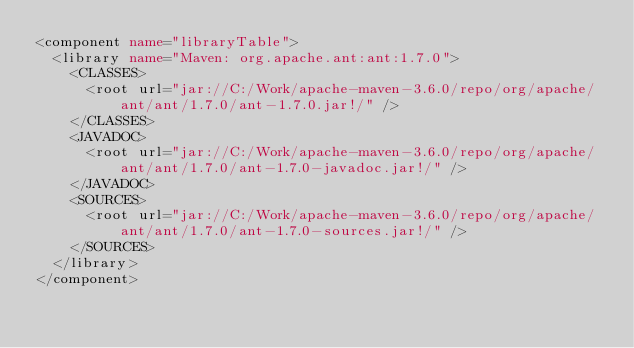Convert code to text. <code><loc_0><loc_0><loc_500><loc_500><_XML_><component name="libraryTable">
  <library name="Maven: org.apache.ant:ant:1.7.0">
    <CLASSES>
      <root url="jar://C:/Work/apache-maven-3.6.0/repo/org/apache/ant/ant/1.7.0/ant-1.7.0.jar!/" />
    </CLASSES>
    <JAVADOC>
      <root url="jar://C:/Work/apache-maven-3.6.0/repo/org/apache/ant/ant/1.7.0/ant-1.7.0-javadoc.jar!/" />
    </JAVADOC>
    <SOURCES>
      <root url="jar://C:/Work/apache-maven-3.6.0/repo/org/apache/ant/ant/1.7.0/ant-1.7.0-sources.jar!/" />
    </SOURCES>
  </library>
</component></code> 